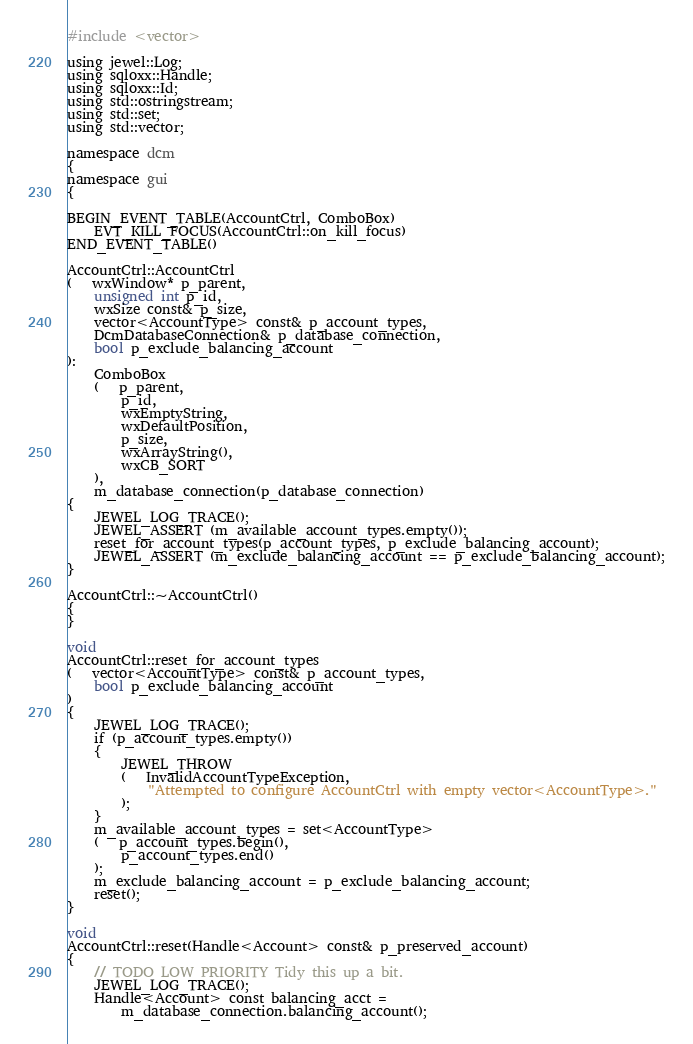Convert code to text. <code><loc_0><loc_0><loc_500><loc_500><_C++_>#include <vector>

using jewel::Log;
using sqloxx::Handle;
using sqloxx::Id;
using std::ostringstream;
using std::set;
using std::vector;

namespace dcm
{
namespace gui
{

BEGIN_EVENT_TABLE(AccountCtrl, ComboBox)
    EVT_KILL_FOCUS(AccountCtrl::on_kill_focus)
END_EVENT_TABLE()

AccountCtrl::AccountCtrl
(   wxWindow* p_parent,
    unsigned int p_id,
    wxSize const& p_size,
    vector<AccountType> const& p_account_types,
    DcmDatabaseConnection& p_database_connection,
    bool p_exclude_balancing_account
):
    ComboBox
    (   p_parent,
        p_id,
        wxEmptyString,
        wxDefaultPosition,
        p_size,
        wxArrayString(),    
        wxCB_SORT
    ),
    m_database_connection(p_database_connection)
{
    JEWEL_LOG_TRACE();
    JEWEL_ASSERT (m_available_account_types.empty());
    reset_for_account_types(p_account_types, p_exclude_balancing_account);
    JEWEL_ASSERT (m_exclude_balancing_account == p_exclude_balancing_account);
}

AccountCtrl::~AccountCtrl()
{
}

void
AccountCtrl::reset_for_account_types
(   vector<AccountType> const& p_account_types,
    bool p_exclude_balancing_account
)
{
    JEWEL_LOG_TRACE();
    if (p_account_types.empty())
    {
        JEWEL_THROW
        (   InvalidAccountTypeException,
            "Attempted to configure AccountCtrl with empty vector<AccountType>."
        );
    }
    m_available_account_types = set<AccountType>
    (   p_account_types.begin(),
        p_account_types.end()
    );
    m_exclude_balancing_account = p_exclude_balancing_account;
    reset();
}

void
AccountCtrl::reset(Handle<Account> const& p_preserved_account)
{
    // TODO LOW PRIORITY Tidy this up a bit.
    JEWEL_LOG_TRACE();
    Handle<Account> const balancing_acct =
        m_database_connection.balancing_account();</code> 